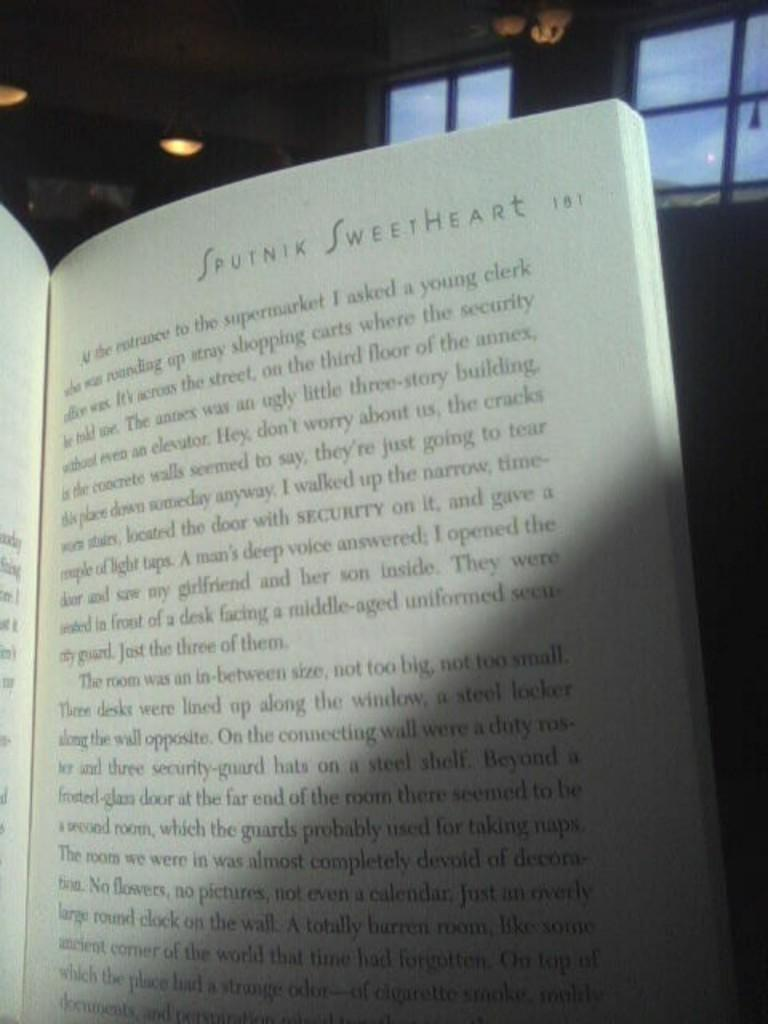<image>
Offer a succinct explanation of the picture presented. A book open to the page of Sputnik Sweetheart. 